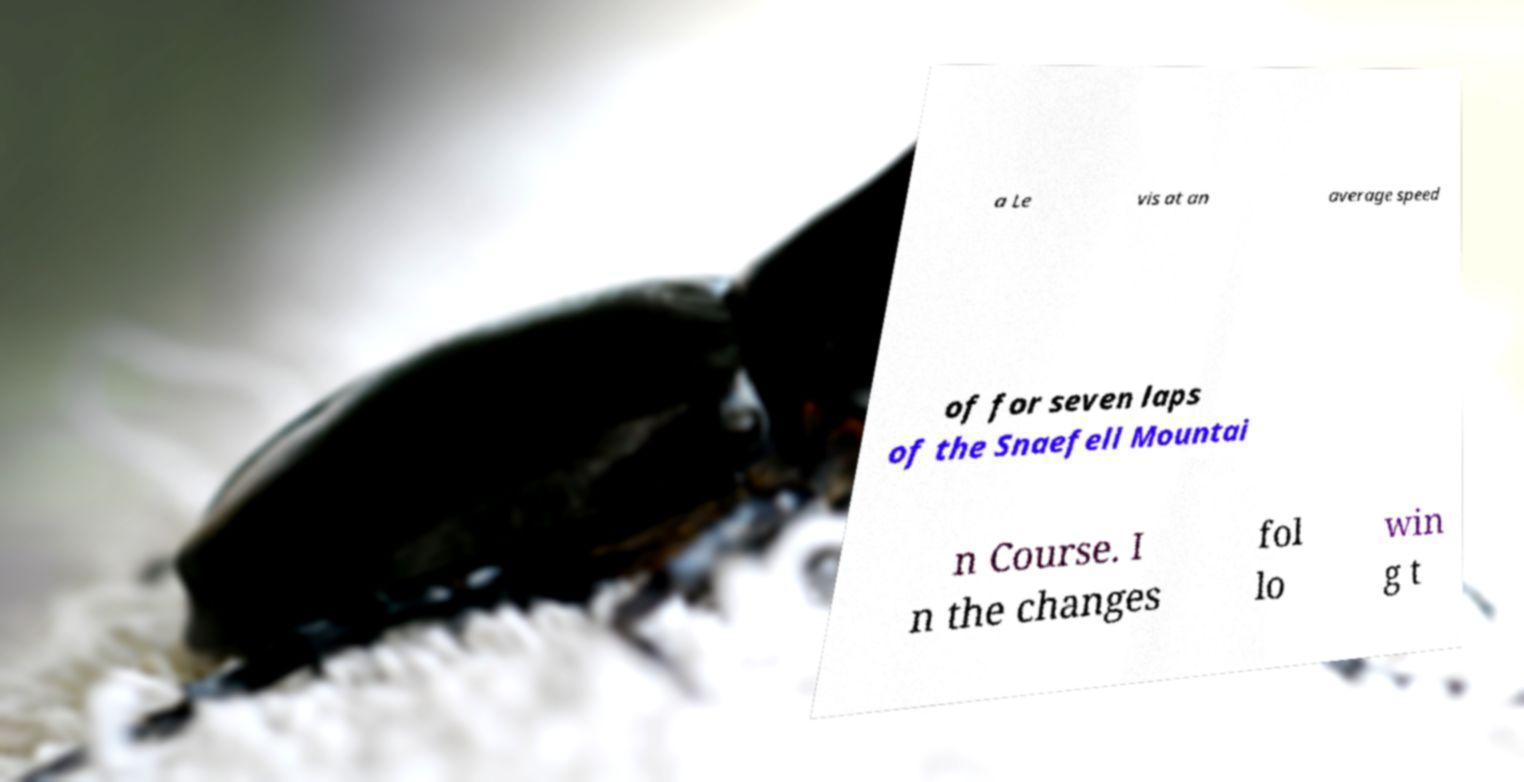Can you accurately transcribe the text from the provided image for me? a Le vis at an average speed of for seven laps of the Snaefell Mountai n Course. I n the changes fol lo win g t 